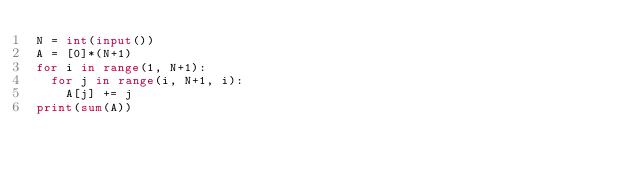Convert code to text. <code><loc_0><loc_0><loc_500><loc_500><_Python_>N = int(input())
A = [0]*(N+1)
for i in range(1, N+1):
  for j in range(i, N+1, i):
    A[j] += j
print(sum(A))</code> 